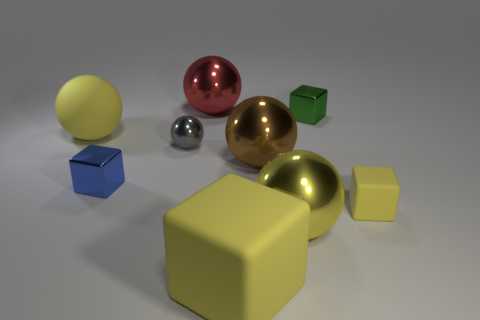Subtract all gray balls. How many balls are left? 4 Subtract all red spheres. How many spheres are left? 4 Subtract all blue balls. Subtract all brown blocks. How many balls are left? 5 Subtract all blocks. How many objects are left? 5 Subtract all yellow rubber objects. Subtract all blue things. How many objects are left? 5 Add 9 tiny green blocks. How many tiny green blocks are left? 10 Add 4 big yellow spheres. How many big yellow spheres exist? 6 Subtract 0 red cylinders. How many objects are left? 9 